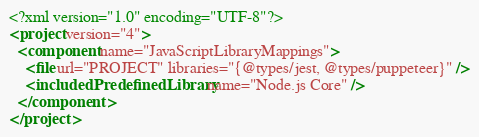<code> <loc_0><loc_0><loc_500><loc_500><_XML_><?xml version="1.0" encoding="UTF-8"?>
<project version="4">
  <component name="JavaScriptLibraryMappings">
    <file url="PROJECT" libraries="{@types/jest, @types/puppeteer}" />
    <includedPredefinedLibrary name="Node.js Core" />
  </component>
</project></code> 